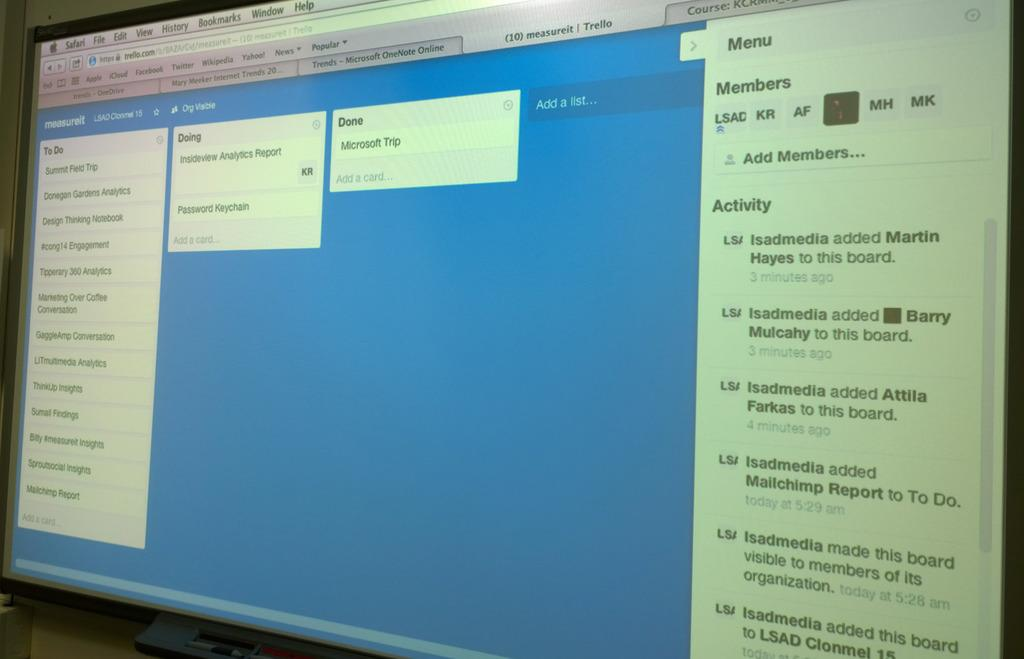<image>
Present a compact description of the photo's key features. A web page that has Microsoft Trip marked as completed. 